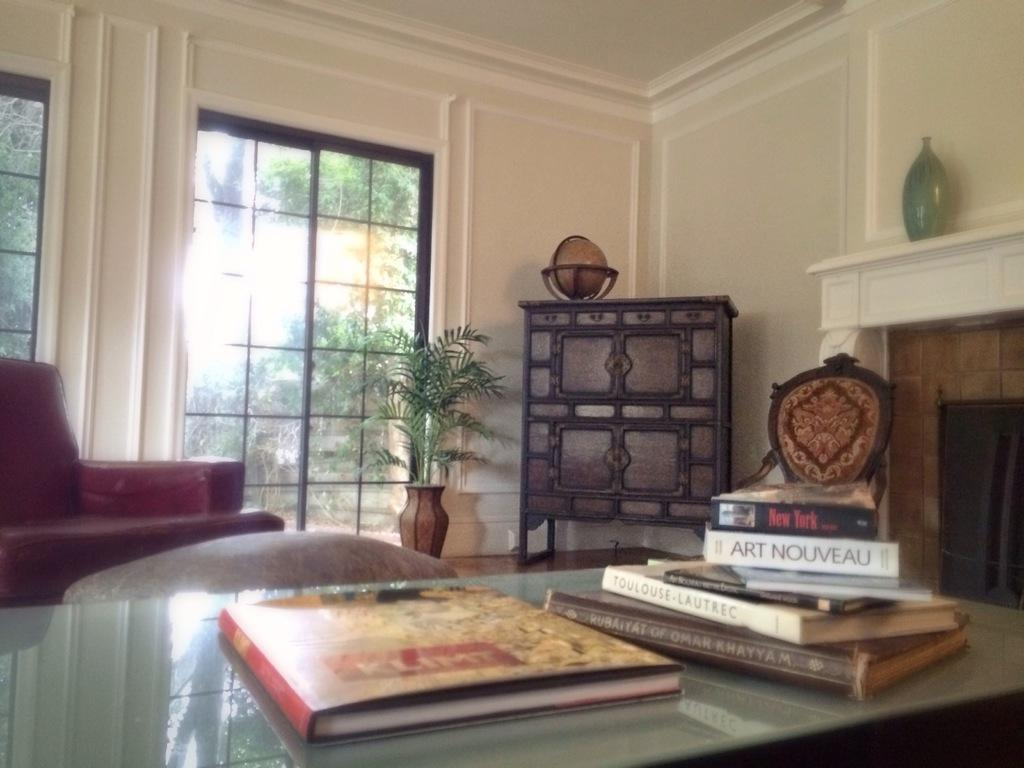Where was the image taken? The image was taken in a home. What piece of furniture is present in the image? There is a table in the image. What object is placed on the table? There is a book on the table. What type of chair is in front of the table? There is a red color chair in front of the table. What is placed in front of the red chair? There is a flower pot in front. What architectural feature is visible in the image? There is a glass window in front. What type of background can be seen in the image? There is a wall visible in the image. How many snails are crawling on the wall in the image? There are no snails visible in the image; the wall is snail-free. 